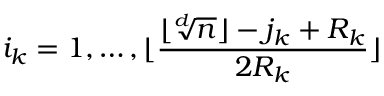<formula> <loc_0><loc_0><loc_500><loc_500>i _ { k } = 1 , \dots , \lfloor \frac { \lfloor \sqrt { [ } d ] { n } \rfloor - j _ { k } + R _ { k } } { 2 R _ { k } } \rfloor</formula> 